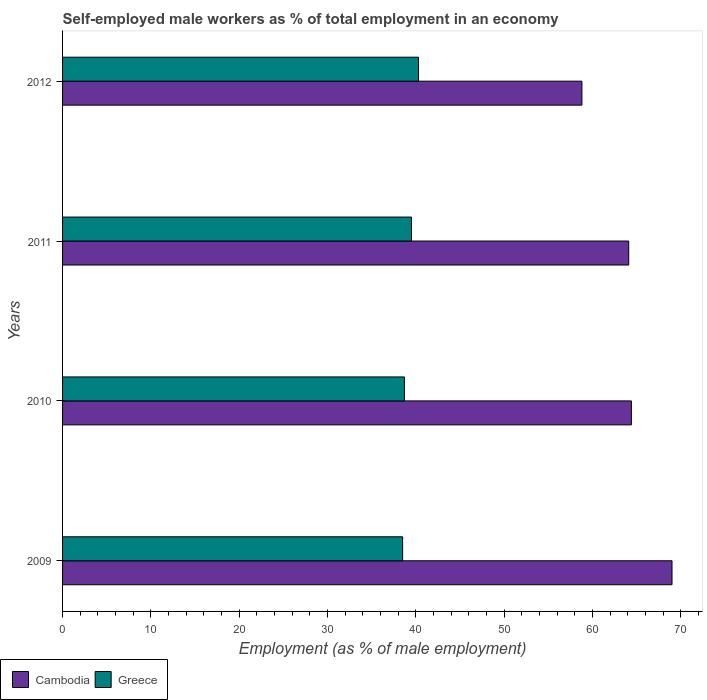How many groups of bars are there?
Offer a very short reply. 4. How many bars are there on the 2nd tick from the top?
Ensure brevity in your answer.  2. How many bars are there on the 3rd tick from the bottom?
Make the answer very short. 2. Across all years, what is the maximum percentage of self-employed male workers in Greece?
Your answer should be compact. 40.3. Across all years, what is the minimum percentage of self-employed male workers in Greece?
Provide a succinct answer. 38.5. In which year was the percentage of self-employed male workers in Greece maximum?
Offer a very short reply. 2012. In which year was the percentage of self-employed male workers in Cambodia minimum?
Give a very brief answer. 2012. What is the total percentage of self-employed male workers in Cambodia in the graph?
Keep it short and to the point. 256.3. What is the difference between the percentage of self-employed male workers in Cambodia in 2009 and that in 2012?
Your response must be concise. 10.2. What is the difference between the percentage of self-employed male workers in Greece in 2009 and the percentage of self-employed male workers in Cambodia in 2012?
Offer a very short reply. -20.3. What is the average percentage of self-employed male workers in Greece per year?
Your answer should be very brief. 39.25. In the year 2009, what is the difference between the percentage of self-employed male workers in Greece and percentage of self-employed male workers in Cambodia?
Provide a succinct answer. -30.5. In how many years, is the percentage of self-employed male workers in Cambodia greater than 12 %?
Keep it short and to the point. 4. What is the ratio of the percentage of self-employed male workers in Greece in 2010 to that in 2011?
Provide a succinct answer. 0.98. What is the difference between the highest and the second highest percentage of self-employed male workers in Cambodia?
Your answer should be compact. 4.6. What is the difference between the highest and the lowest percentage of self-employed male workers in Greece?
Offer a very short reply. 1.8. Is the sum of the percentage of self-employed male workers in Cambodia in 2010 and 2011 greater than the maximum percentage of self-employed male workers in Greece across all years?
Offer a very short reply. Yes. What does the 2nd bar from the top in 2012 represents?
Provide a succinct answer. Cambodia. What does the 1st bar from the bottom in 2012 represents?
Offer a terse response. Cambodia. How many years are there in the graph?
Your answer should be very brief. 4. What is the difference between two consecutive major ticks on the X-axis?
Ensure brevity in your answer.  10. Are the values on the major ticks of X-axis written in scientific E-notation?
Provide a short and direct response. No. Does the graph contain grids?
Make the answer very short. No. How many legend labels are there?
Provide a short and direct response. 2. How are the legend labels stacked?
Your answer should be compact. Horizontal. What is the title of the graph?
Provide a short and direct response. Self-employed male workers as % of total employment in an economy. Does "United Kingdom" appear as one of the legend labels in the graph?
Your answer should be compact. No. What is the label or title of the X-axis?
Provide a short and direct response. Employment (as % of male employment). What is the label or title of the Y-axis?
Your answer should be very brief. Years. What is the Employment (as % of male employment) of Greece in 2009?
Your response must be concise. 38.5. What is the Employment (as % of male employment) in Cambodia in 2010?
Give a very brief answer. 64.4. What is the Employment (as % of male employment) of Greece in 2010?
Provide a succinct answer. 38.7. What is the Employment (as % of male employment) in Cambodia in 2011?
Offer a terse response. 64.1. What is the Employment (as % of male employment) of Greece in 2011?
Provide a succinct answer. 39.5. What is the Employment (as % of male employment) of Cambodia in 2012?
Your answer should be compact. 58.8. What is the Employment (as % of male employment) of Greece in 2012?
Give a very brief answer. 40.3. Across all years, what is the maximum Employment (as % of male employment) of Cambodia?
Provide a short and direct response. 69. Across all years, what is the maximum Employment (as % of male employment) in Greece?
Provide a short and direct response. 40.3. Across all years, what is the minimum Employment (as % of male employment) in Cambodia?
Provide a succinct answer. 58.8. Across all years, what is the minimum Employment (as % of male employment) of Greece?
Make the answer very short. 38.5. What is the total Employment (as % of male employment) in Cambodia in the graph?
Offer a terse response. 256.3. What is the total Employment (as % of male employment) in Greece in the graph?
Make the answer very short. 157. What is the difference between the Employment (as % of male employment) of Cambodia in 2009 and that in 2010?
Your answer should be compact. 4.6. What is the difference between the Employment (as % of male employment) in Greece in 2009 and that in 2011?
Give a very brief answer. -1. What is the difference between the Employment (as % of male employment) of Cambodia in 2009 and that in 2012?
Provide a short and direct response. 10.2. What is the difference between the Employment (as % of male employment) of Greece in 2009 and that in 2012?
Give a very brief answer. -1.8. What is the difference between the Employment (as % of male employment) in Cambodia in 2010 and that in 2012?
Ensure brevity in your answer.  5.6. What is the difference between the Employment (as % of male employment) in Cambodia in 2011 and that in 2012?
Give a very brief answer. 5.3. What is the difference between the Employment (as % of male employment) in Cambodia in 2009 and the Employment (as % of male employment) in Greece in 2010?
Your response must be concise. 30.3. What is the difference between the Employment (as % of male employment) of Cambodia in 2009 and the Employment (as % of male employment) of Greece in 2011?
Offer a terse response. 29.5. What is the difference between the Employment (as % of male employment) of Cambodia in 2009 and the Employment (as % of male employment) of Greece in 2012?
Provide a short and direct response. 28.7. What is the difference between the Employment (as % of male employment) in Cambodia in 2010 and the Employment (as % of male employment) in Greece in 2011?
Make the answer very short. 24.9. What is the difference between the Employment (as % of male employment) in Cambodia in 2010 and the Employment (as % of male employment) in Greece in 2012?
Your response must be concise. 24.1. What is the difference between the Employment (as % of male employment) of Cambodia in 2011 and the Employment (as % of male employment) of Greece in 2012?
Provide a succinct answer. 23.8. What is the average Employment (as % of male employment) of Cambodia per year?
Your response must be concise. 64.08. What is the average Employment (as % of male employment) in Greece per year?
Offer a very short reply. 39.25. In the year 2009, what is the difference between the Employment (as % of male employment) of Cambodia and Employment (as % of male employment) of Greece?
Make the answer very short. 30.5. In the year 2010, what is the difference between the Employment (as % of male employment) of Cambodia and Employment (as % of male employment) of Greece?
Provide a succinct answer. 25.7. In the year 2011, what is the difference between the Employment (as % of male employment) of Cambodia and Employment (as % of male employment) of Greece?
Your answer should be very brief. 24.6. What is the ratio of the Employment (as % of male employment) of Cambodia in 2009 to that in 2010?
Offer a terse response. 1.07. What is the ratio of the Employment (as % of male employment) in Cambodia in 2009 to that in 2011?
Provide a short and direct response. 1.08. What is the ratio of the Employment (as % of male employment) in Greece in 2009 to that in 2011?
Your answer should be compact. 0.97. What is the ratio of the Employment (as % of male employment) of Cambodia in 2009 to that in 2012?
Your response must be concise. 1.17. What is the ratio of the Employment (as % of male employment) of Greece in 2009 to that in 2012?
Your answer should be very brief. 0.96. What is the ratio of the Employment (as % of male employment) of Greece in 2010 to that in 2011?
Give a very brief answer. 0.98. What is the ratio of the Employment (as % of male employment) of Cambodia in 2010 to that in 2012?
Provide a succinct answer. 1.1. What is the ratio of the Employment (as % of male employment) of Greece in 2010 to that in 2012?
Your response must be concise. 0.96. What is the ratio of the Employment (as % of male employment) in Cambodia in 2011 to that in 2012?
Your answer should be very brief. 1.09. What is the ratio of the Employment (as % of male employment) of Greece in 2011 to that in 2012?
Your answer should be very brief. 0.98. What is the difference between the highest and the second highest Employment (as % of male employment) in Greece?
Your answer should be very brief. 0.8. What is the difference between the highest and the lowest Employment (as % of male employment) of Cambodia?
Offer a very short reply. 10.2. 